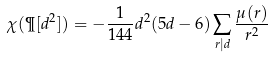Convert formula to latex. <formula><loc_0><loc_0><loc_500><loc_500>\chi ( \P [ d ^ { 2 } ] ) = - \frac { 1 } { 1 4 4 } d ^ { 2 } ( 5 d - 6 ) \sum _ { r | d } \frac { \mu ( r ) } { r ^ { 2 } }</formula> 